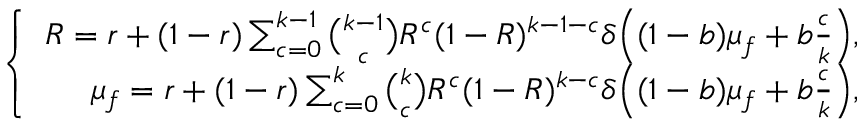Convert formula to latex. <formula><loc_0><loc_0><loc_500><loc_500>\left \{ \begin{array} { r } { R = r + ( 1 - r ) \sum _ { c = 0 } ^ { k - 1 } \binom { k - 1 } { c } R ^ { c } ( 1 - R ) ^ { k - 1 - c } \delta \left ( ( 1 - b ) \mu _ { f } + b \frac { c } { k } \right ) , } \\ { \mu _ { f } = r + ( 1 - r ) \sum _ { c = 0 } ^ { k } \binom { k } { c } R ^ { c } ( 1 - R ) ^ { k - c } \delta \left ( ( 1 - b ) \mu _ { f } + b \frac { c } { k } \right ) , } \end{array}</formula> 